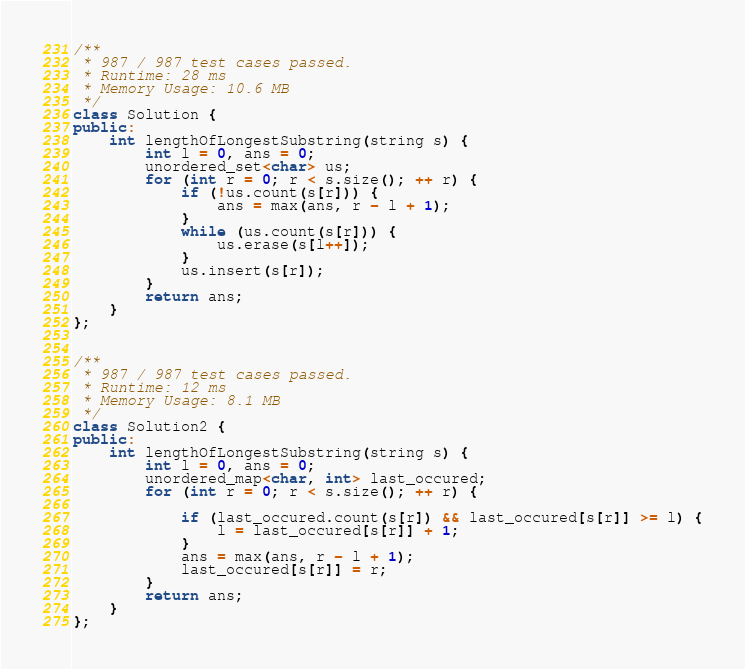Convert code to text. <code><loc_0><loc_0><loc_500><loc_500><_C++_>/**
 * 987 / 987 test cases passed.
 * Runtime: 28 ms
 * Memory Usage: 10.6 MB 
 */
class Solution {
public:
    int lengthOfLongestSubstring(string s) {
        int l = 0, ans = 0;
        unordered_set<char> us;
        for (int r = 0; r < s.size(); ++ r) {
            if (!us.count(s[r])) {
                ans = max(ans, r - l + 1);
            }
            while (us.count(s[r])) {
                us.erase(s[l++]);
            } 
            us.insert(s[r]);
        }
        return ans;
    }
};


/**
 * 987 / 987 test cases passed.
 * Runtime: 12 ms
 * Memory Usage: 8.1 MB 
 */
class Solution2 {
public:
    int lengthOfLongestSubstring(string s) {
        int l = 0, ans = 0;
        unordered_map<char, int> last_occured;
        for (int r = 0; r < s.size(); ++ r) {

            if (last_occured.count(s[r]) && last_occured[s[r]] >= l) {
                l = last_occured[s[r]] + 1;
            }
            ans = max(ans, r - l + 1);
            last_occured[s[r]] = r;
        }
        return ans;
    }
};
</code> 